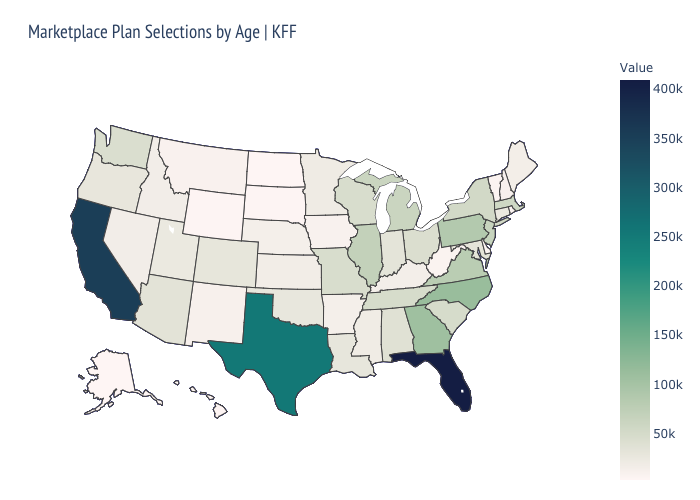Does Pennsylvania have the highest value in the Northeast?
Quick response, please. Yes. Among the states that border Wisconsin , does Michigan have the highest value?
Concise answer only. No. Among the states that border New Jersey , which have the lowest value?
Give a very brief answer. Delaware. Among the states that border Florida , does Alabama have the highest value?
Give a very brief answer. No. Does Pennsylvania have the lowest value in the Northeast?
Give a very brief answer. No. 